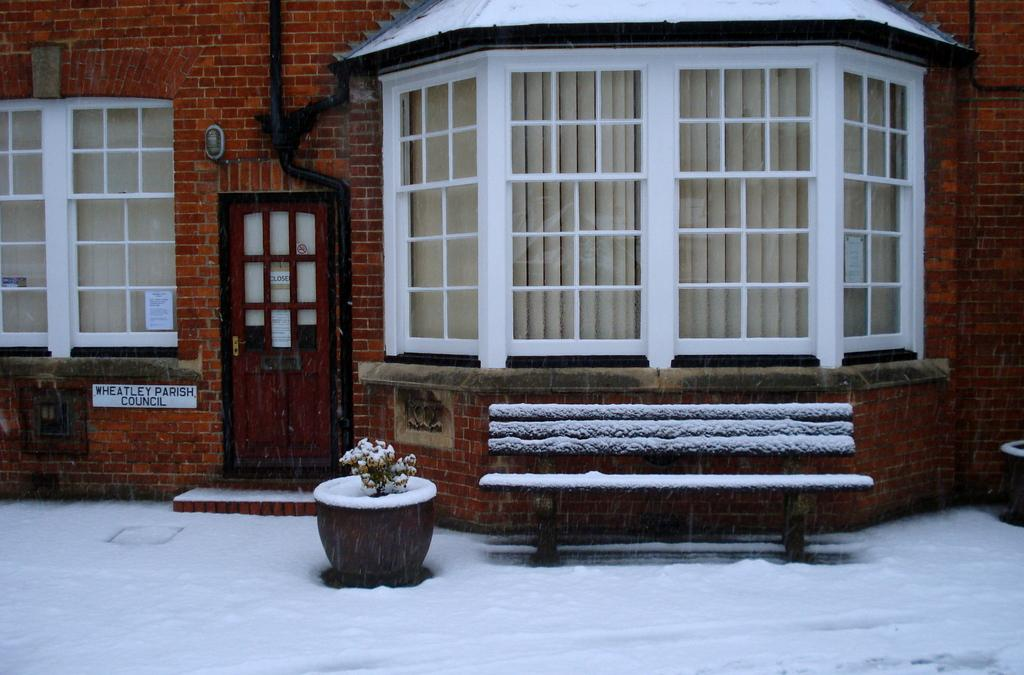What type of structure is visible in the image? There is a building in the image. What is the color of the door on the building? There is a white door in the image. Is there any identification on the building? Yes, there is a name plate in the image. What type of seating is available in the image? There is a bench in the image. What is the weather like in the image? There is white snow in the image, indicating a cold or wintery environment. Are there any plants visible in the image? Yes, there is a flower pot and a plant in the image. How does the society in the image contribute to the development of the plant? There is no indication of a society or development in the image; it primarily features a building, a bench, and a plant. 